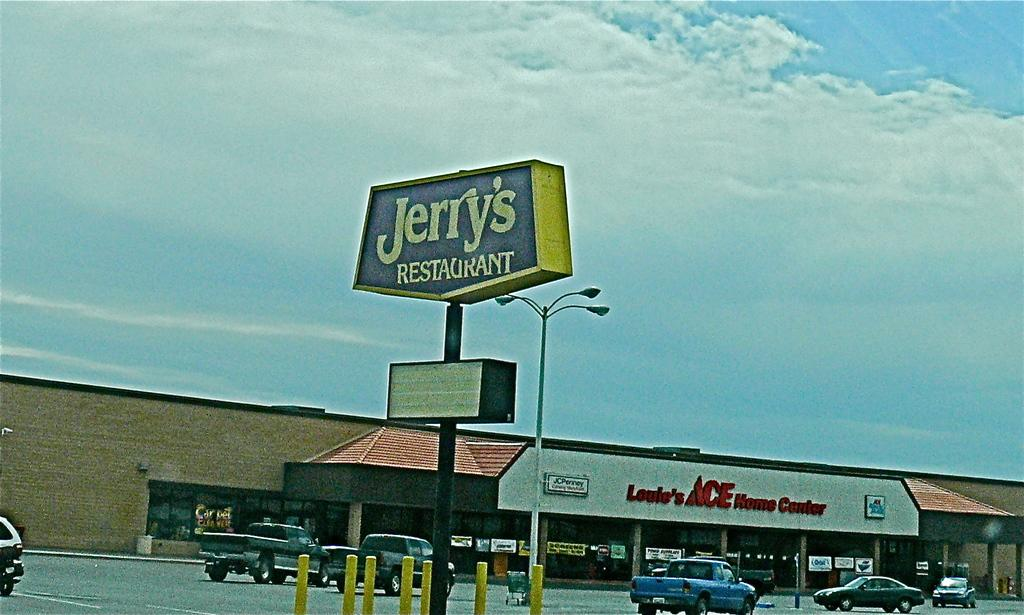<image>
Create a compact narrative representing the image presented. A photo of Jerry's Restaurant outside of an Ace store. 